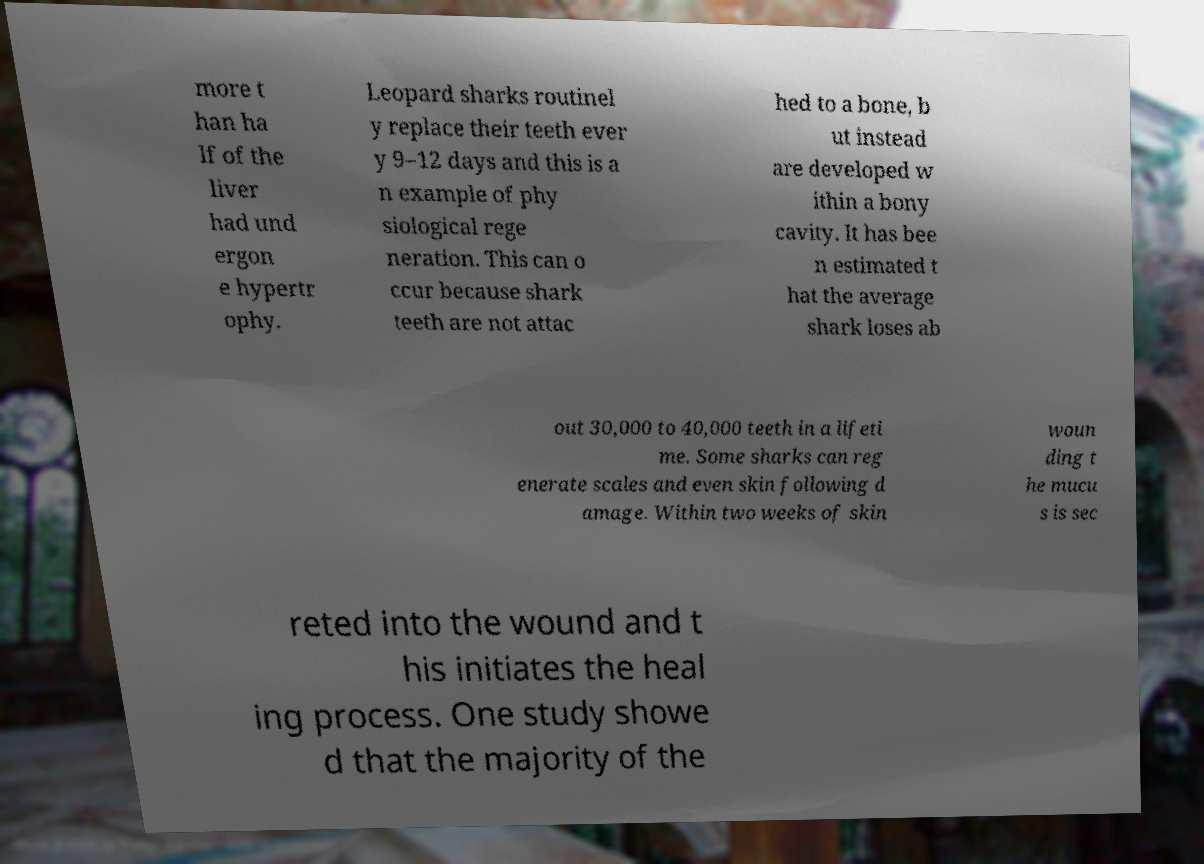Could you assist in decoding the text presented in this image and type it out clearly? more t han ha lf of the liver had und ergon e hypertr ophy. Leopard sharks routinel y replace their teeth ever y 9–12 days and this is a n example of phy siological rege neration. This can o ccur because shark teeth are not attac hed to a bone, b ut instead are developed w ithin a bony cavity. It has bee n estimated t hat the average shark loses ab out 30,000 to 40,000 teeth in a lifeti me. Some sharks can reg enerate scales and even skin following d amage. Within two weeks of skin woun ding t he mucu s is sec reted into the wound and t his initiates the heal ing process. One study showe d that the majority of the 